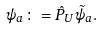Convert formula to latex. <formula><loc_0><loc_0><loc_500><loc_500>\psi _ { a } \colon = \hat { P } _ { U } \tilde { \psi } _ { a } .</formula> 